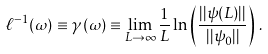<formula> <loc_0><loc_0><loc_500><loc_500>\ell ^ { - 1 } ( \omega ) \equiv \gamma ( \omega ) \equiv \lim _ { L \to \infty } \frac { 1 } { L } \ln \left ( \frac { | | \psi ( L ) | | } { | | \psi _ { 0 } | | } \right ) \, .</formula> 